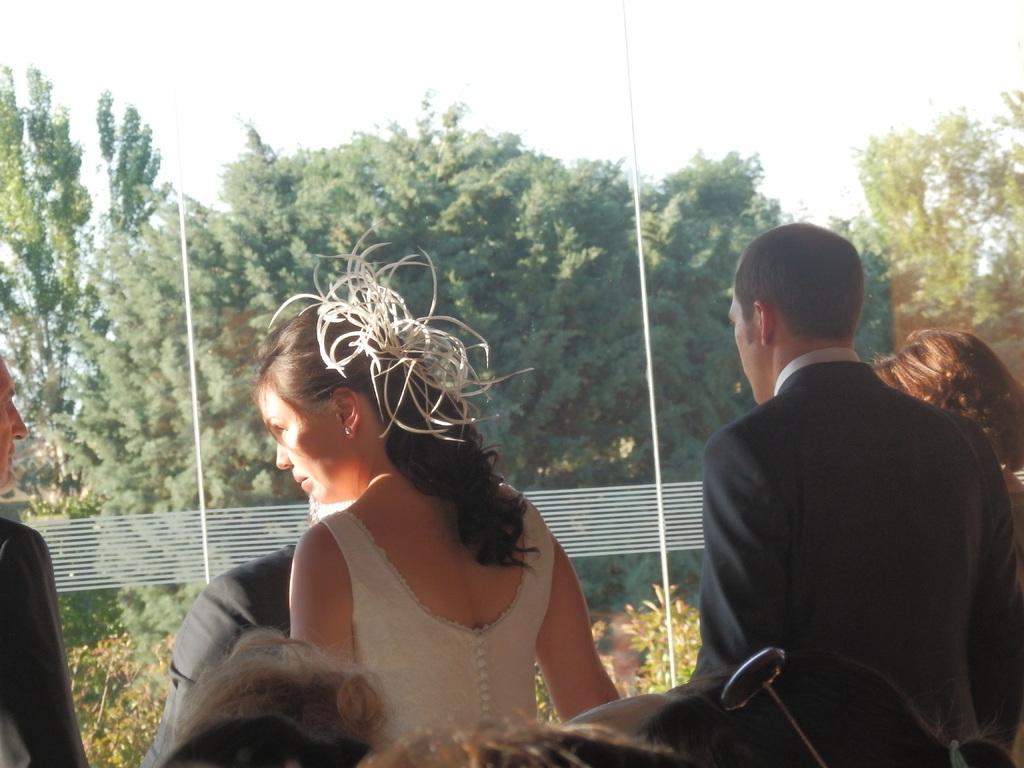Describe this image in one or two sentences. In the image we can see there are people wearing clothes. Here we can see glass window and out of the window we can see trees, plants and the sky. 